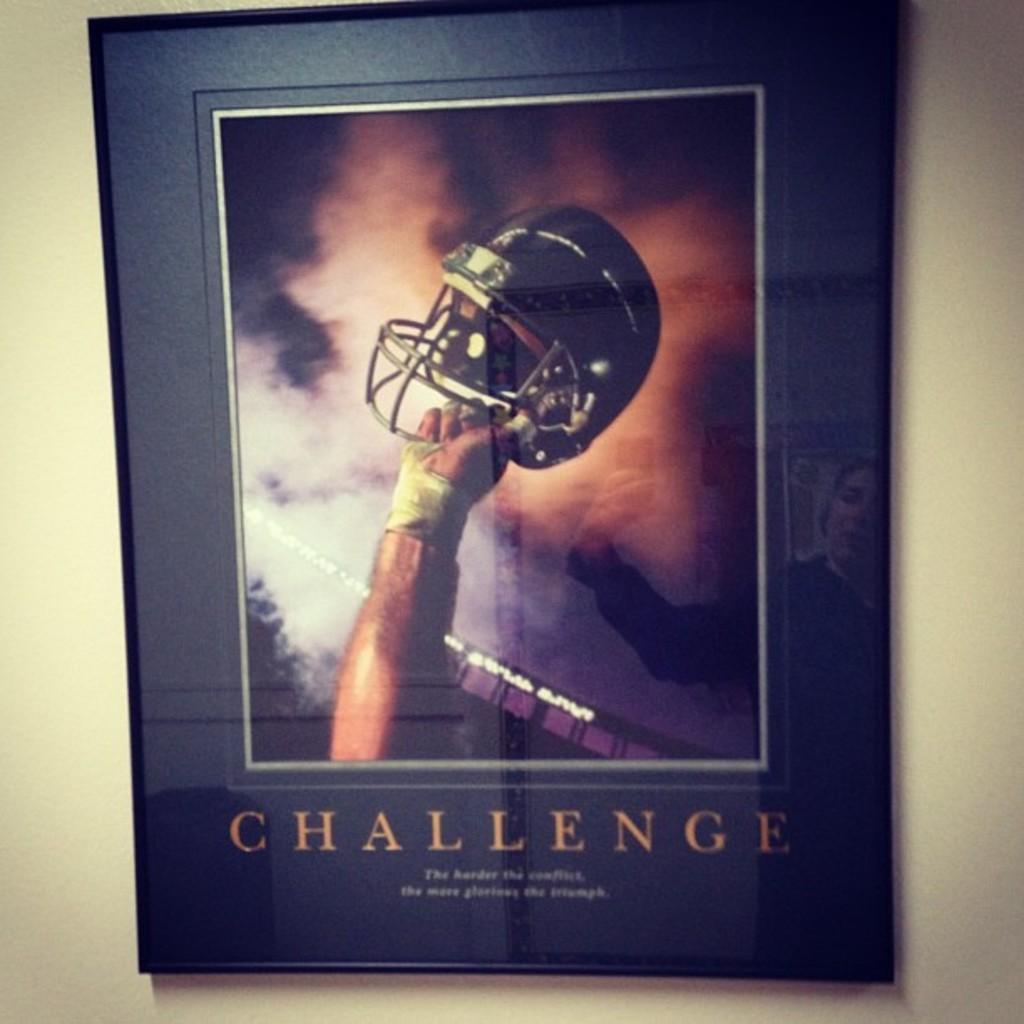Please provide a concise description of this image. In the foreground of this image, there is a poster on the wall. In the poster, there is a person's hand holding a helmet and text on the bottom. 